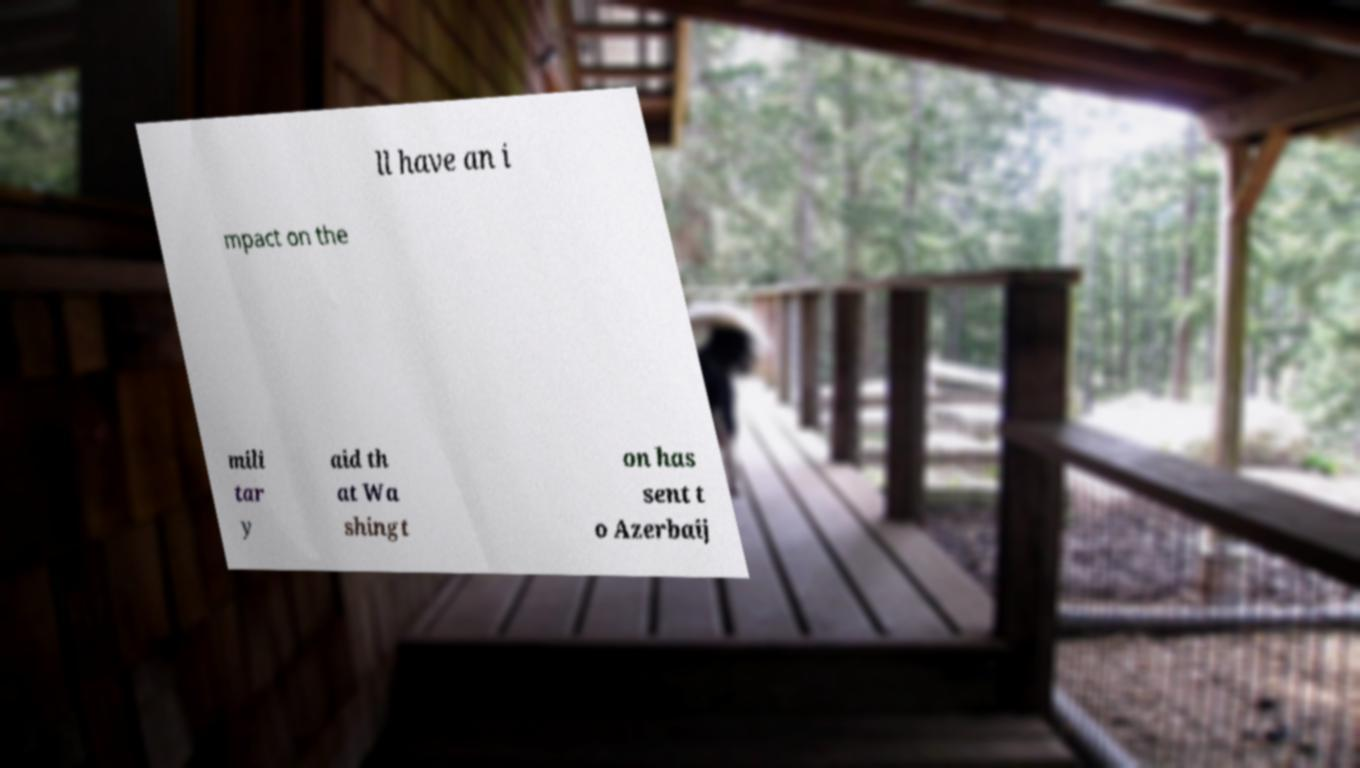What messages or text are displayed in this image? I need them in a readable, typed format. ll have an i mpact on the mili tar y aid th at Wa shingt on has sent t o Azerbaij 